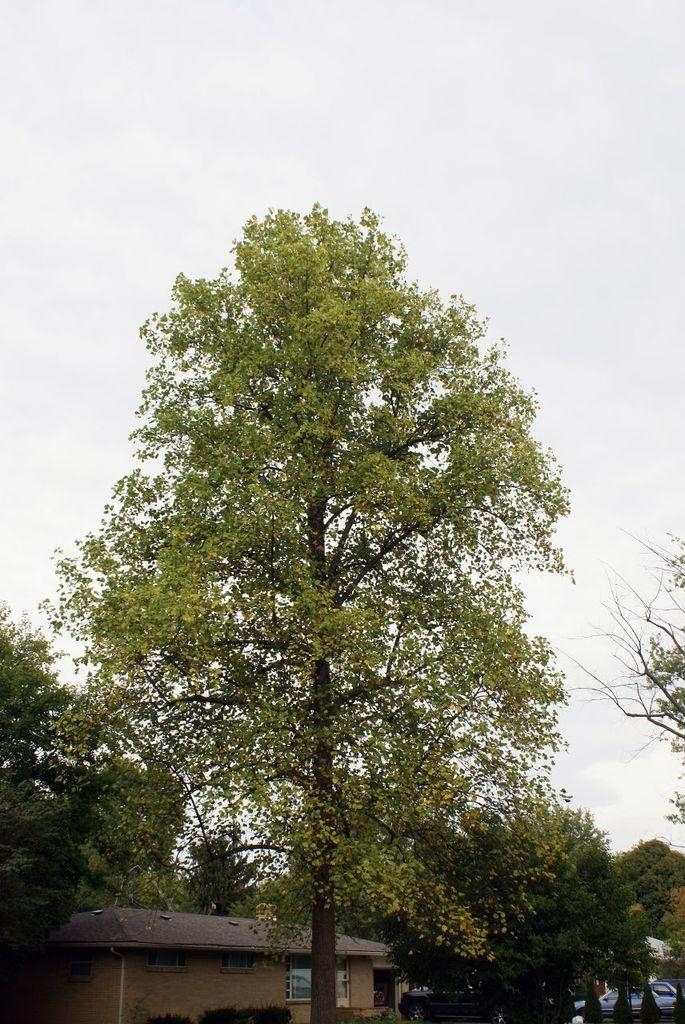What is located in the center of the image? There are trees in the center of the image. What structure can be seen at the bottom of the image? There is a shed at the bottom of the image. What type of vehicles are visible at the bottom of the image? Cars are visible at the bottom of the image. What is visible at the top of the image? The sky is visible at the top of the image. How does the income of the trees in the image affect the impulse of the cars at the bottom? There is no information about the income of the trees or the impulse of the cars in the image, as these topics are not mentioned in the provided facts. 